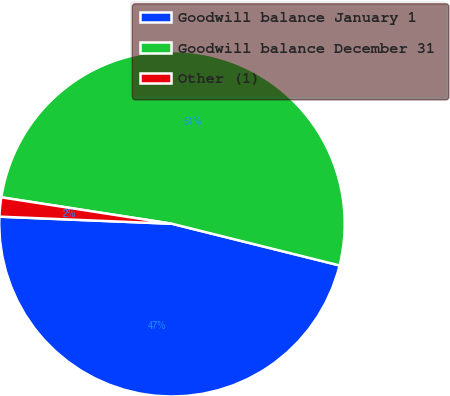Convert chart to OTSL. <chart><loc_0><loc_0><loc_500><loc_500><pie_chart><fcel>Goodwill balance January 1<fcel>Goodwill balance December 31<fcel>Other (1)<nl><fcel>46.78%<fcel>51.44%<fcel>1.79%<nl></chart> 